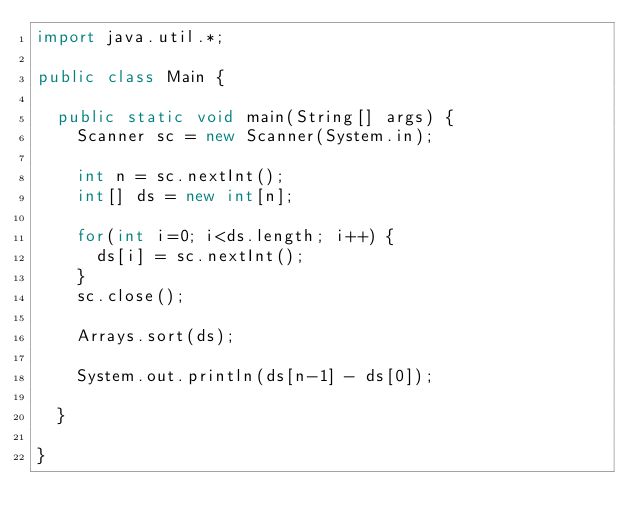<code> <loc_0><loc_0><loc_500><loc_500><_Java_>import java.util.*;

public class Main {

	public static void main(String[] args) {
		Scanner sc = new Scanner(System.in);
		
		int n = sc.nextInt();
		int[] ds = new int[n];
		
		for(int i=0; i<ds.length; i++) {
			ds[i] = sc.nextInt();
		}
		sc.close();
		
		Arrays.sort(ds);
		
		System.out.println(ds[n-1] - ds[0]);

	}

}
</code> 